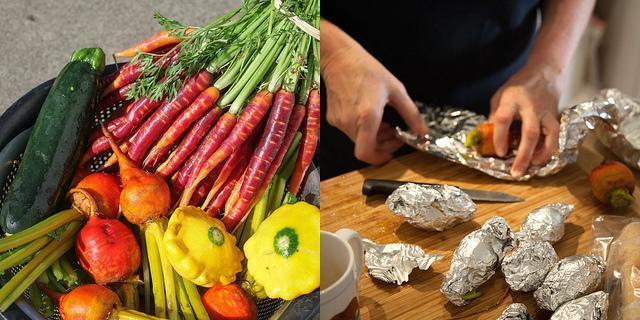How many dining tables can you see?
Give a very brief answer. 1. How many red kites are there?
Give a very brief answer. 0. 